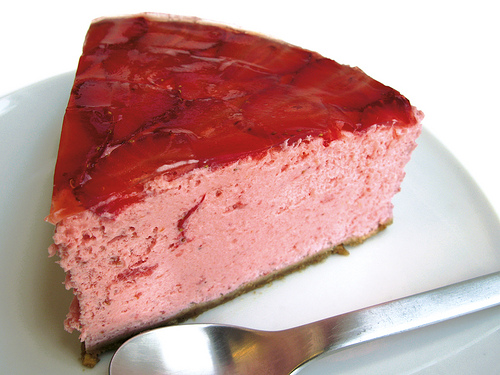<image>
Can you confirm if the desert is in the plate? Yes. The desert is contained within or inside the plate, showing a containment relationship. 